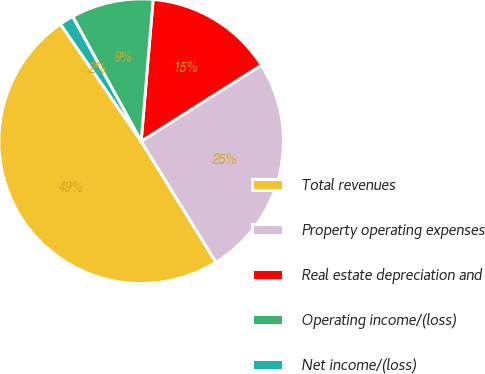Convert chart to OTSL. <chart><loc_0><loc_0><loc_500><loc_500><pie_chart><fcel>Total revenues<fcel>Property operating expenses<fcel>Real estate depreciation and<fcel>Operating income/(loss)<fcel>Net income/(loss)<nl><fcel>49.2%<fcel>25.18%<fcel>14.67%<fcel>9.34%<fcel>1.6%<nl></chart> 